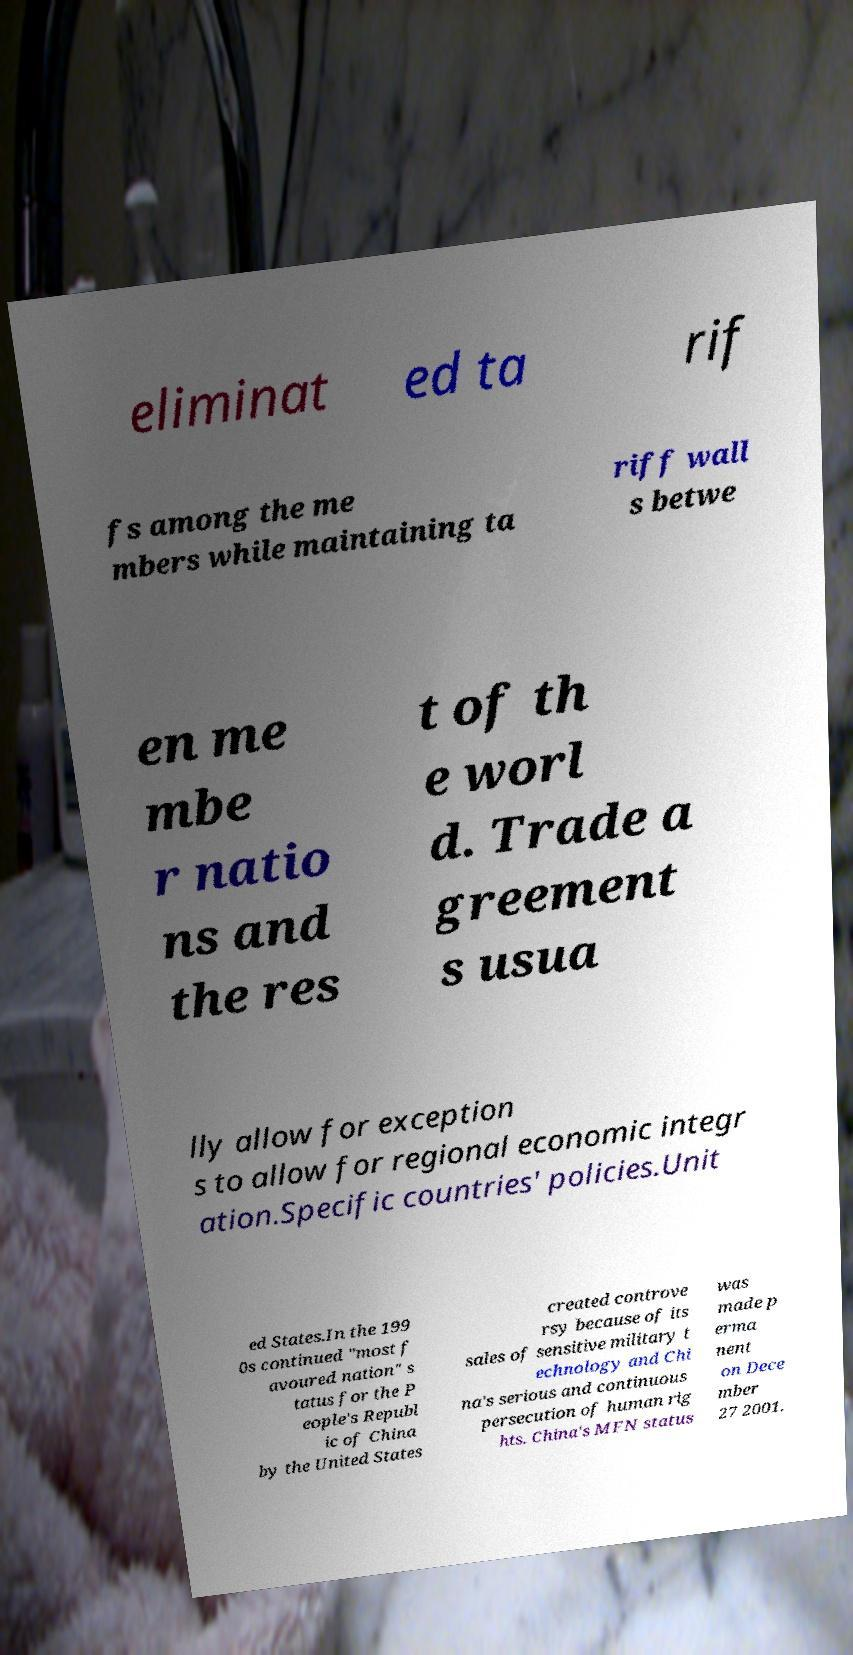Can you accurately transcribe the text from the provided image for me? eliminat ed ta rif fs among the me mbers while maintaining ta riff wall s betwe en me mbe r natio ns and the res t of th e worl d. Trade a greement s usua lly allow for exception s to allow for regional economic integr ation.Specific countries' policies.Unit ed States.In the 199 0s continued "most f avoured nation" s tatus for the P eople's Republ ic of China by the United States created controve rsy because of its sales of sensitive military t echnology and Chi na's serious and continuous persecution of human rig hts. China's MFN status was made p erma nent on Dece mber 27 2001. 